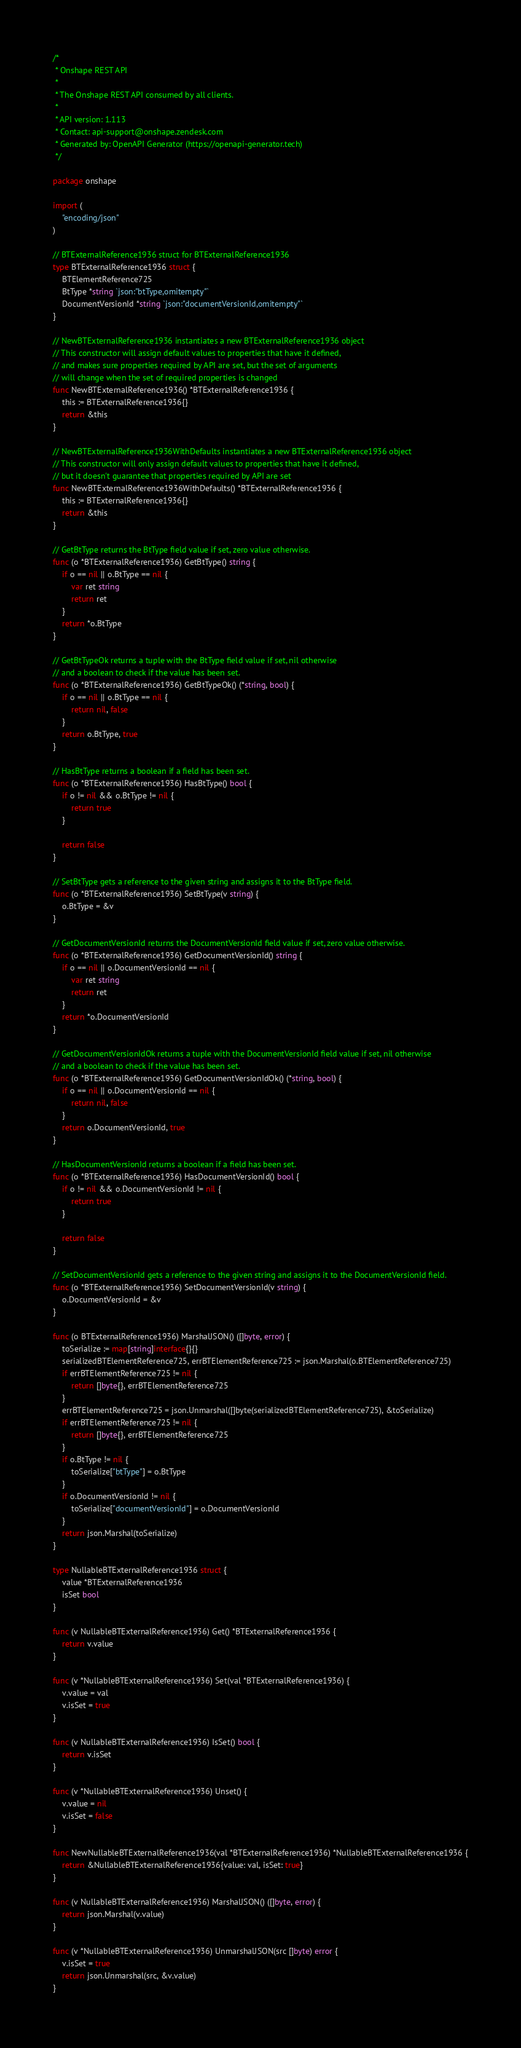<code> <loc_0><loc_0><loc_500><loc_500><_Go_>/*
 * Onshape REST API
 *
 * The Onshape REST API consumed by all clients.
 *
 * API version: 1.113
 * Contact: api-support@onshape.zendesk.com
 * Generated by: OpenAPI Generator (https://openapi-generator.tech)
 */

package onshape

import (
	"encoding/json"
)

// BTExternalReference1936 struct for BTExternalReference1936
type BTExternalReference1936 struct {
	BTElementReference725
	BtType *string `json:"btType,omitempty"`
	DocumentVersionId *string `json:"documentVersionId,omitempty"`
}

// NewBTExternalReference1936 instantiates a new BTExternalReference1936 object
// This constructor will assign default values to properties that have it defined,
// and makes sure properties required by API are set, but the set of arguments
// will change when the set of required properties is changed
func NewBTExternalReference1936() *BTExternalReference1936 {
	this := BTExternalReference1936{}
	return &this
}

// NewBTExternalReference1936WithDefaults instantiates a new BTExternalReference1936 object
// This constructor will only assign default values to properties that have it defined,
// but it doesn't guarantee that properties required by API are set
func NewBTExternalReference1936WithDefaults() *BTExternalReference1936 {
	this := BTExternalReference1936{}
	return &this
}

// GetBtType returns the BtType field value if set, zero value otherwise.
func (o *BTExternalReference1936) GetBtType() string {
	if o == nil || o.BtType == nil {
		var ret string
		return ret
	}
	return *o.BtType
}

// GetBtTypeOk returns a tuple with the BtType field value if set, nil otherwise
// and a boolean to check if the value has been set.
func (o *BTExternalReference1936) GetBtTypeOk() (*string, bool) {
	if o == nil || o.BtType == nil {
		return nil, false
	}
	return o.BtType, true
}

// HasBtType returns a boolean if a field has been set.
func (o *BTExternalReference1936) HasBtType() bool {
	if o != nil && o.BtType != nil {
		return true
	}

	return false
}

// SetBtType gets a reference to the given string and assigns it to the BtType field.
func (o *BTExternalReference1936) SetBtType(v string) {
	o.BtType = &v
}

// GetDocumentVersionId returns the DocumentVersionId field value if set, zero value otherwise.
func (o *BTExternalReference1936) GetDocumentVersionId() string {
	if o == nil || o.DocumentVersionId == nil {
		var ret string
		return ret
	}
	return *o.DocumentVersionId
}

// GetDocumentVersionIdOk returns a tuple with the DocumentVersionId field value if set, nil otherwise
// and a boolean to check if the value has been set.
func (o *BTExternalReference1936) GetDocumentVersionIdOk() (*string, bool) {
	if o == nil || o.DocumentVersionId == nil {
		return nil, false
	}
	return o.DocumentVersionId, true
}

// HasDocumentVersionId returns a boolean if a field has been set.
func (o *BTExternalReference1936) HasDocumentVersionId() bool {
	if o != nil && o.DocumentVersionId != nil {
		return true
	}

	return false
}

// SetDocumentVersionId gets a reference to the given string and assigns it to the DocumentVersionId field.
func (o *BTExternalReference1936) SetDocumentVersionId(v string) {
	o.DocumentVersionId = &v
}

func (o BTExternalReference1936) MarshalJSON() ([]byte, error) {
	toSerialize := map[string]interface{}{}
	serializedBTElementReference725, errBTElementReference725 := json.Marshal(o.BTElementReference725)
	if errBTElementReference725 != nil {
		return []byte{}, errBTElementReference725
	}
	errBTElementReference725 = json.Unmarshal([]byte(serializedBTElementReference725), &toSerialize)
	if errBTElementReference725 != nil {
		return []byte{}, errBTElementReference725
	}
	if o.BtType != nil {
		toSerialize["btType"] = o.BtType
	}
	if o.DocumentVersionId != nil {
		toSerialize["documentVersionId"] = o.DocumentVersionId
	}
	return json.Marshal(toSerialize)
}

type NullableBTExternalReference1936 struct {
	value *BTExternalReference1936
	isSet bool
}

func (v NullableBTExternalReference1936) Get() *BTExternalReference1936 {
	return v.value
}

func (v *NullableBTExternalReference1936) Set(val *BTExternalReference1936) {
	v.value = val
	v.isSet = true
}

func (v NullableBTExternalReference1936) IsSet() bool {
	return v.isSet
}

func (v *NullableBTExternalReference1936) Unset() {
	v.value = nil
	v.isSet = false
}

func NewNullableBTExternalReference1936(val *BTExternalReference1936) *NullableBTExternalReference1936 {
	return &NullableBTExternalReference1936{value: val, isSet: true}
}

func (v NullableBTExternalReference1936) MarshalJSON() ([]byte, error) {
	return json.Marshal(v.value)
}

func (v *NullableBTExternalReference1936) UnmarshalJSON(src []byte) error {
	v.isSet = true
	return json.Unmarshal(src, &v.value)
}
</code> 